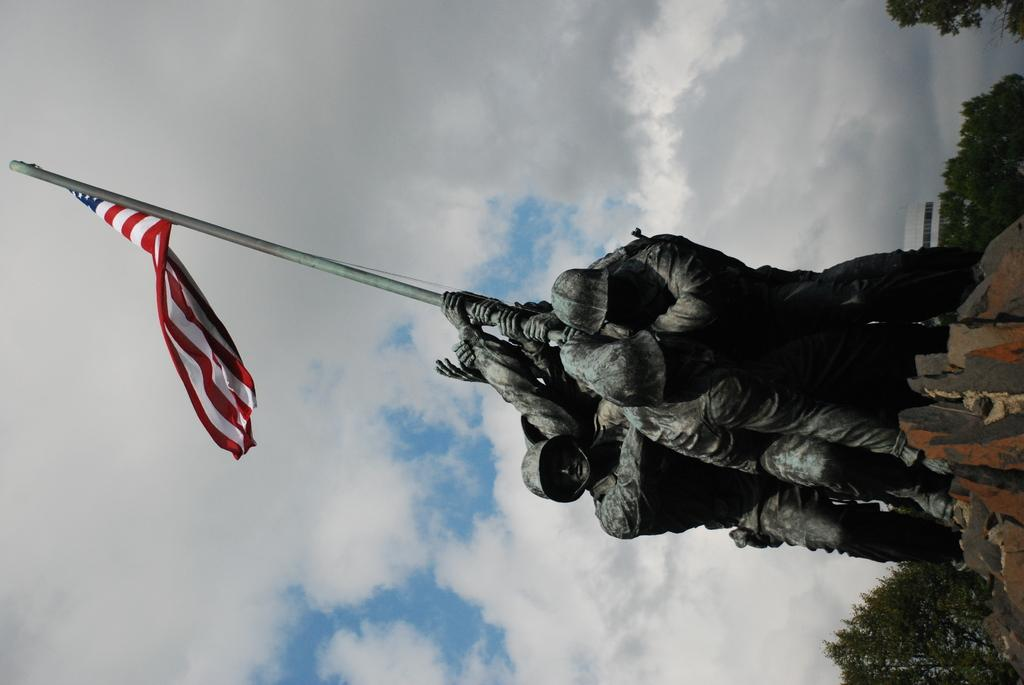What is the main subject in the image? There is a statue in the image. What else can be seen in the image besides the statue? There is a flag in the image. What can be seen in the background of the image? There are buildings, trees, and the sky visible in the background of the image. What type of quince is being used to hold the flag in the image? There is no quince present in the image, and the flag is not being held by any fruit. How many clocks can be seen in the image? There are no clocks visible in the image. 